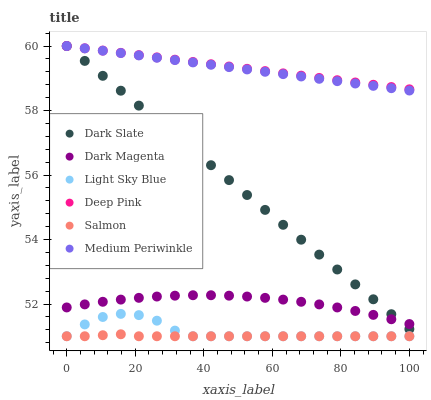Does Salmon have the minimum area under the curve?
Answer yes or no. Yes. Does Deep Pink have the maximum area under the curve?
Answer yes or no. Yes. Does Dark Magenta have the minimum area under the curve?
Answer yes or no. No. Does Dark Magenta have the maximum area under the curve?
Answer yes or no. No. Is Dark Slate the smoothest?
Answer yes or no. Yes. Is Light Sky Blue the roughest?
Answer yes or no. Yes. Is Dark Magenta the smoothest?
Answer yes or no. No. Is Dark Magenta the roughest?
Answer yes or no. No. Does Salmon have the lowest value?
Answer yes or no. Yes. Does Dark Magenta have the lowest value?
Answer yes or no. No. Does Dark Slate have the highest value?
Answer yes or no. Yes. Does Dark Magenta have the highest value?
Answer yes or no. No. Is Salmon less than Dark Slate?
Answer yes or no. Yes. Is Deep Pink greater than Light Sky Blue?
Answer yes or no. Yes. Does Medium Periwinkle intersect Deep Pink?
Answer yes or no. Yes. Is Medium Periwinkle less than Deep Pink?
Answer yes or no. No. Is Medium Periwinkle greater than Deep Pink?
Answer yes or no. No. Does Salmon intersect Dark Slate?
Answer yes or no. No. 